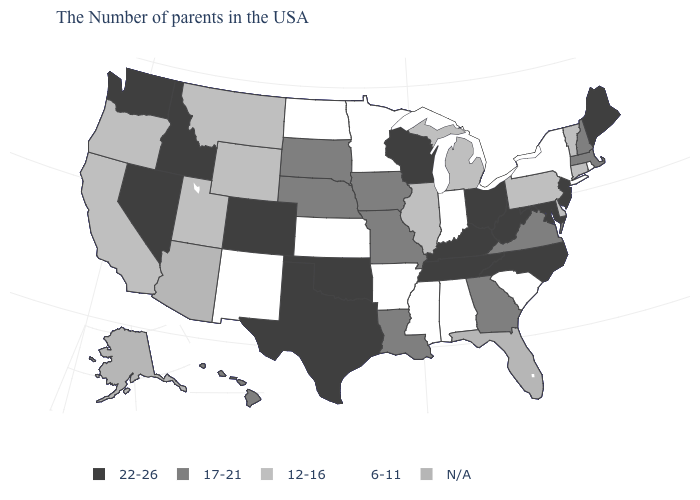Among the states that border Florida , which have the lowest value?
Be succinct. Alabama. What is the value of Mississippi?
Concise answer only. 6-11. Among the states that border South Dakota , does Iowa have the highest value?
Keep it brief. Yes. Does the map have missing data?
Quick response, please. Yes. Name the states that have a value in the range 6-11?
Keep it brief. Rhode Island, New York, South Carolina, Indiana, Alabama, Mississippi, Arkansas, Minnesota, Kansas, North Dakota, New Mexico. What is the highest value in states that border Ohio?
Give a very brief answer. 22-26. What is the lowest value in the USA?
Answer briefly. 6-11. Name the states that have a value in the range 6-11?
Short answer required. Rhode Island, New York, South Carolina, Indiana, Alabama, Mississippi, Arkansas, Minnesota, Kansas, North Dakota, New Mexico. Name the states that have a value in the range 17-21?
Quick response, please. Massachusetts, New Hampshire, Virginia, Georgia, Louisiana, Missouri, Iowa, Nebraska, South Dakota, Hawaii. What is the highest value in states that border Georgia?
Write a very short answer. 22-26. Does Nevada have the highest value in the West?
Write a very short answer. Yes. What is the lowest value in the USA?
Quick response, please. 6-11. How many symbols are there in the legend?
Write a very short answer. 5. Does the first symbol in the legend represent the smallest category?
Answer briefly. No. 